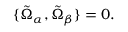<formula> <loc_0><loc_0><loc_500><loc_500>\{ \tilde { \Omega } _ { \alpha } , \tilde { \Omega } _ { \beta } \} = 0 .</formula> 